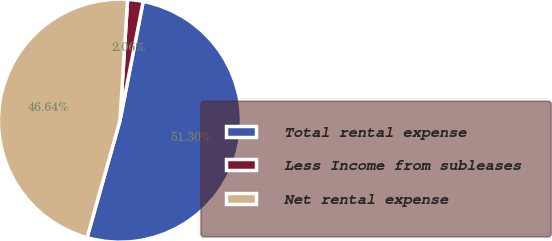<chart> <loc_0><loc_0><loc_500><loc_500><pie_chart><fcel>Total rental expense<fcel>Less Income from subleases<fcel>Net rental expense<nl><fcel>51.3%<fcel>2.06%<fcel>46.64%<nl></chart> 